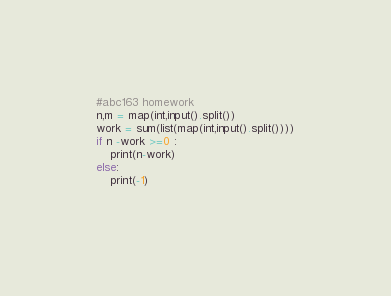<code> <loc_0><loc_0><loc_500><loc_500><_Python_>#abc163 homework
n,m = map(int,input().split())
work = sum(list(map(int,input().split())))
if n -work >=0 :
    print(n-work)
else:
    print(-1)
    </code> 